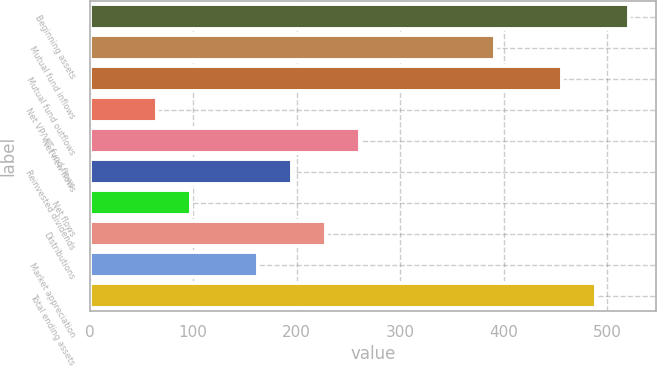Convert chart to OTSL. <chart><loc_0><loc_0><loc_500><loc_500><bar_chart><fcel>Beginning assets<fcel>Mutual fund inflows<fcel>Mutual fund outflows<fcel>Net VP/VIT fund flows<fcel>Net new flows<fcel>Reinvested dividends<fcel>Net flows<fcel>Distributions<fcel>Market appreciation<fcel>Total ending assets<nl><fcel>521.7<fcel>391.3<fcel>456.5<fcel>65.3<fcel>260.9<fcel>195.7<fcel>97.9<fcel>228.3<fcel>163.1<fcel>489.1<nl></chart> 